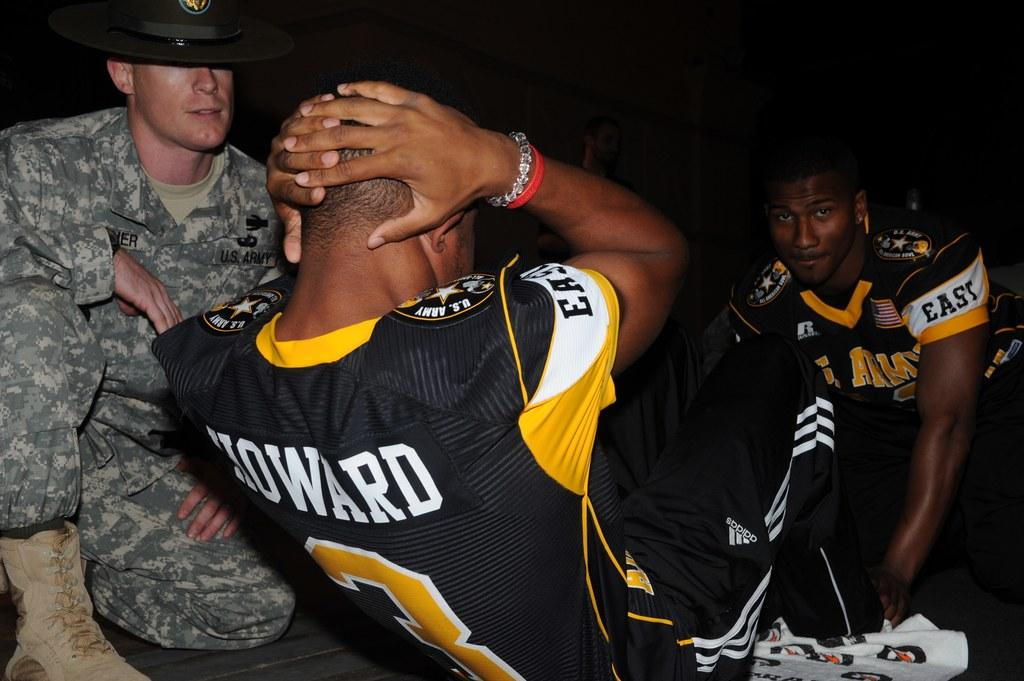<image>
Render a clear and concise summary of the photo. the name Howard on the back of a person's jersey 